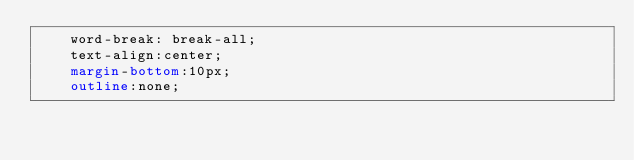Convert code to text. <code><loc_0><loc_0><loc_500><loc_500><_CSS_>    word-break: break-all;
    text-align:center;
    margin-bottom:10px;
    outline:none;</code> 